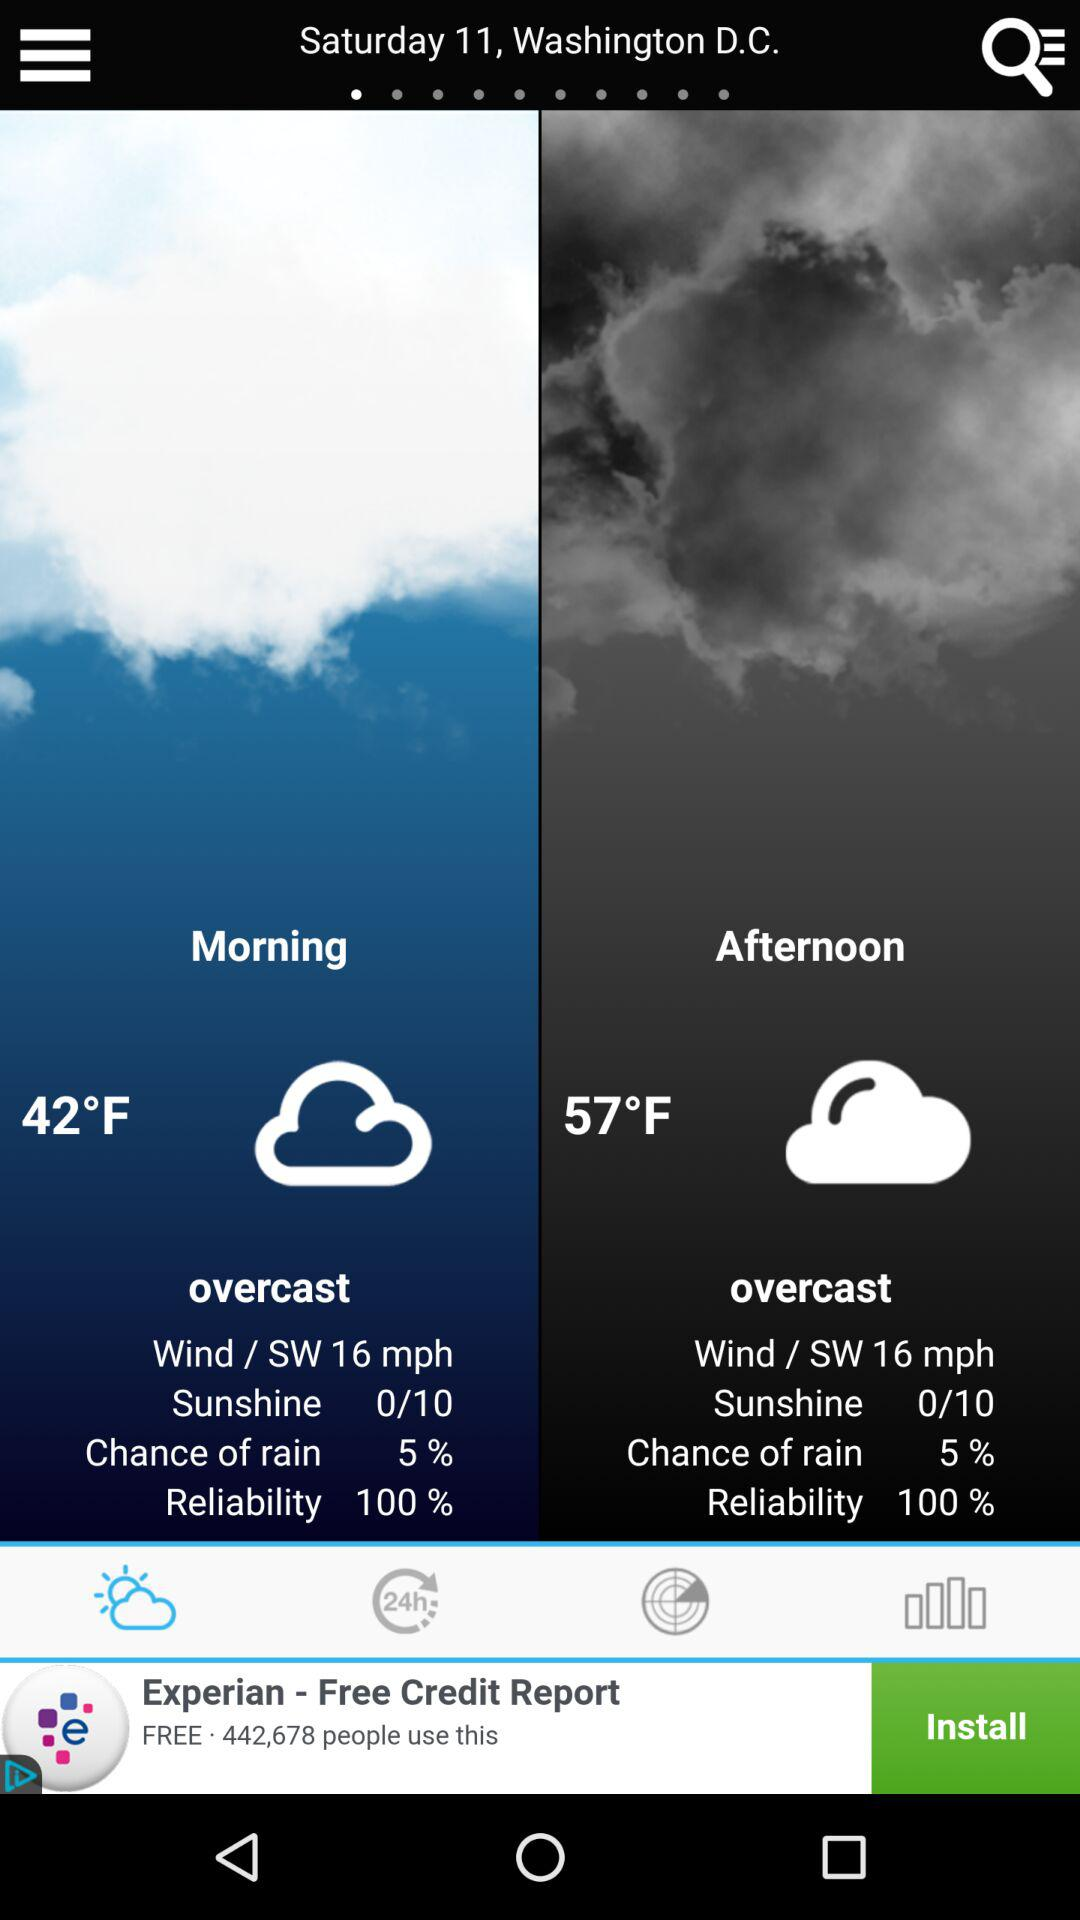What is the percentage chance of rain in the afternoon?
Answer the question using a single word or phrase. 5% 